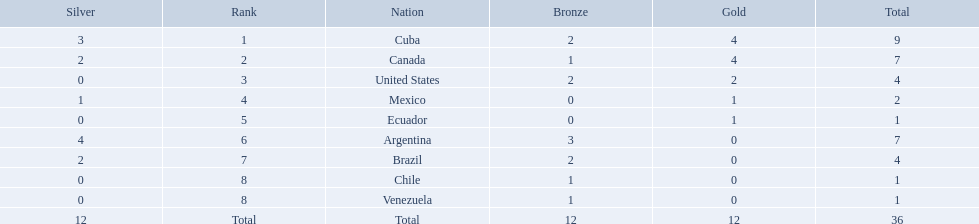Which nations participated? Cuba, Canada, United States, Mexico, Ecuador, Argentina, Brazil, Chile, Venezuela. Which nations won gold? Cuba, Canada, United States, Mexico, Ecuador. Which nations did not win silver? United States, Ecuador, Chile, Venezuela. Out of those countries previously listed, which nation won gold? United States. 